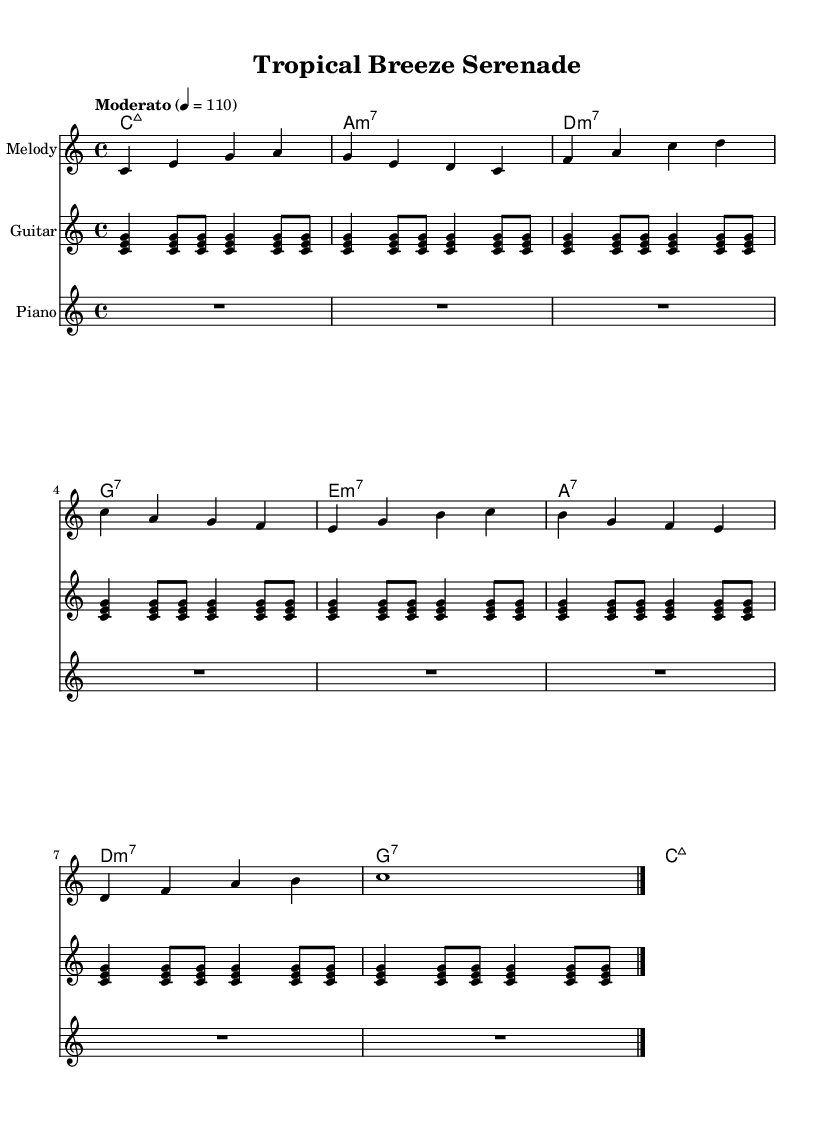What is the key signature of this music? The key signature indicated is C major, which has no sharps or flats shown on the staff.
Answer: C major What is the time signature of the piece? The time signature is displayed as 4/4, which means there are four beats per measure and the quarter note gets one beat.
Answer: 4/4 What is the tempo marking of the piece? The tempo marking is indicated as "Moderato" with a metronome marking of 110, which instructs the performer to play at a moderate and steady pace.
Answer: Moderato, 110 How many measures are in the melody section? Counting the measures in the melody part, we have eight measures total leading up to the final bar.
Answer: 8 What is the harmonic progression used in the piece? The chord progression starts with C major 7, followed by A minor 7, D minor 7, G7, and others, creating a sequence typical in bossa nova.
Answer: Cmaj7, Am7, Dm7, G7.. What instruments are indicated in the score? The score includes three instruments: an acoustic guitar for the melody, a guitar part, and a piano part, all of which are common in bossa nova and samba.
Answer: Acoustic guitar, Guitar, Piano What style is this music indicative of? The combination of the tempo, harmonies, and rhythms suggest a fusion of bossa nova and samba, which are known for their relaxing qualities and intricate rhythms.
Answer: Bossa nova and samba fusion 